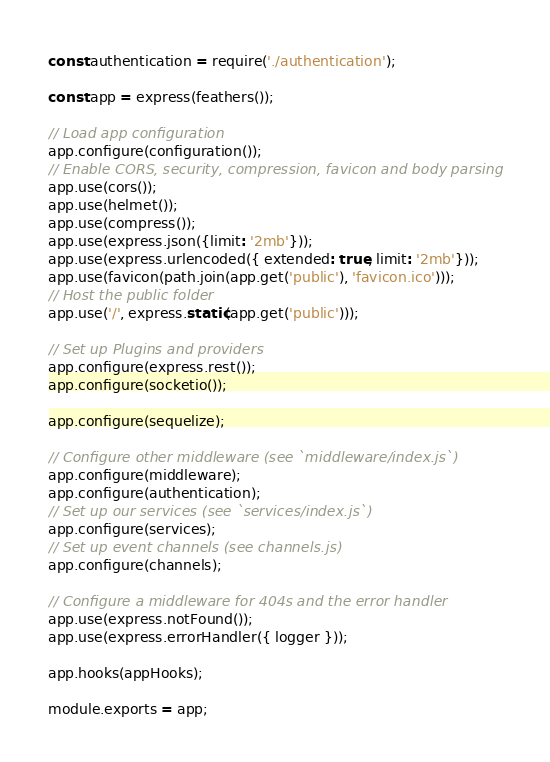Convert code to text. <code><loc_0><loc_0><loc_500><loc_500><_JavaScript_>const authentication = require('./authentication');

const app = express(feathers());

// Load app configuration
app.configure(configuration());
// Enable CORS, security, compression, favicon and body parsing
app.use(cors());
app.use(helmet());
app.use(compress());
app.use(express.json({limit: '2mb'}));
app.use(express.urlencoded({ extended: true, limit: '2mb'}));
app.use(favicon(path.join(app.get('public'), 'favicon.ico')));
// Host the public folder
app.use('/', express.static(app.get('public')));

// Set up Plugins and providers
app.configure(express.rest());
app.configure(socketio());

app.configure(sequelize);

// Configure other middleware (see `middleware/index.js`)
app.configure(middleware);
app.configure(authentication);
// Set up our services (see `services/index.js`)
app.configure(services);
// Set up event channels (see channels.js)
app.configure(channels);

// Configure a middleware for 404s and the error handler
app.use(express.notFound());
app.use(express.errorHandler({ logger }));

app.hooks(appHooks);

module.exports = app;
</code> 